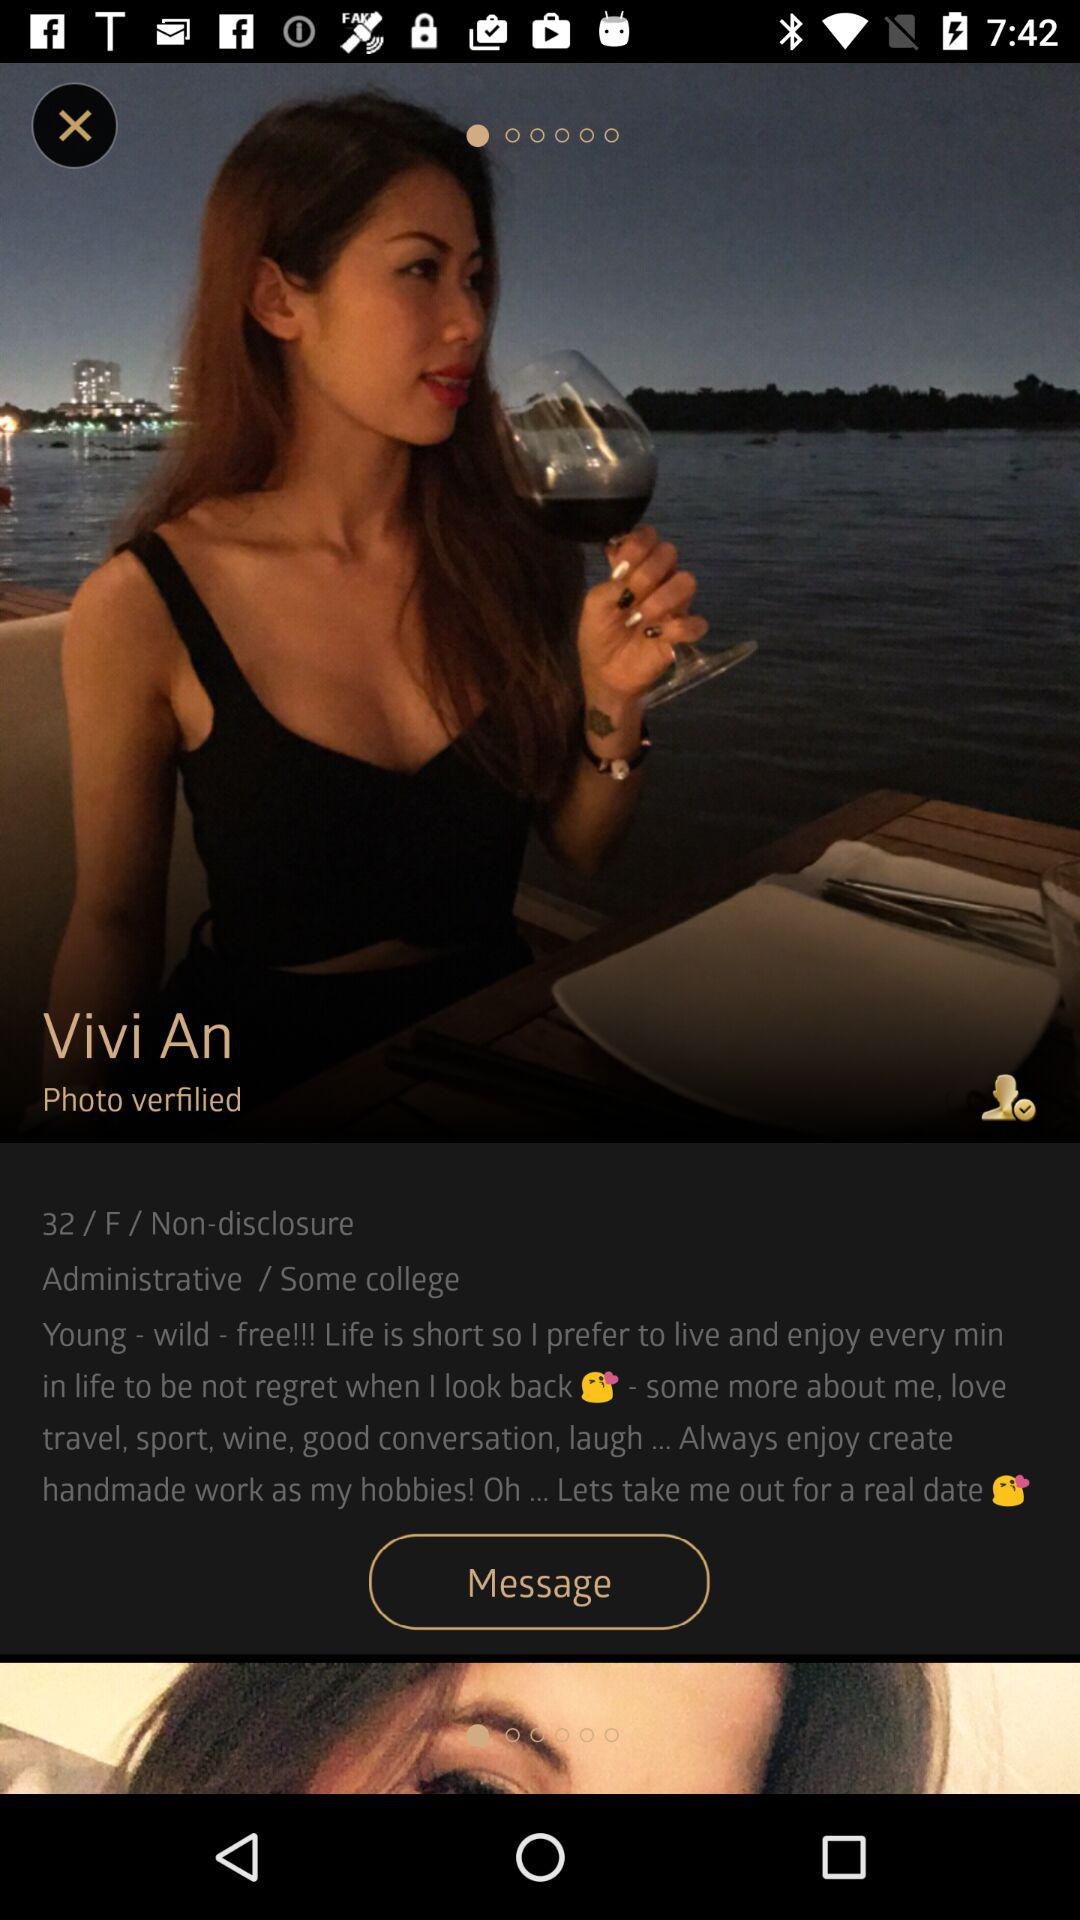What's the gender of Vivi An? The gender of Vivi An is female. 